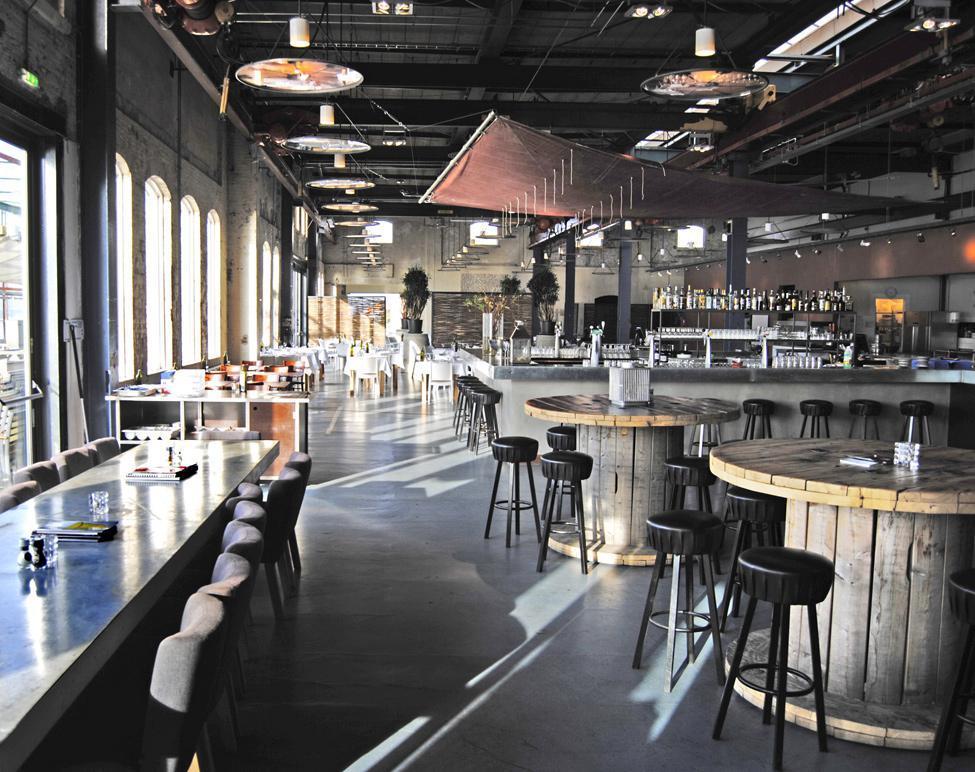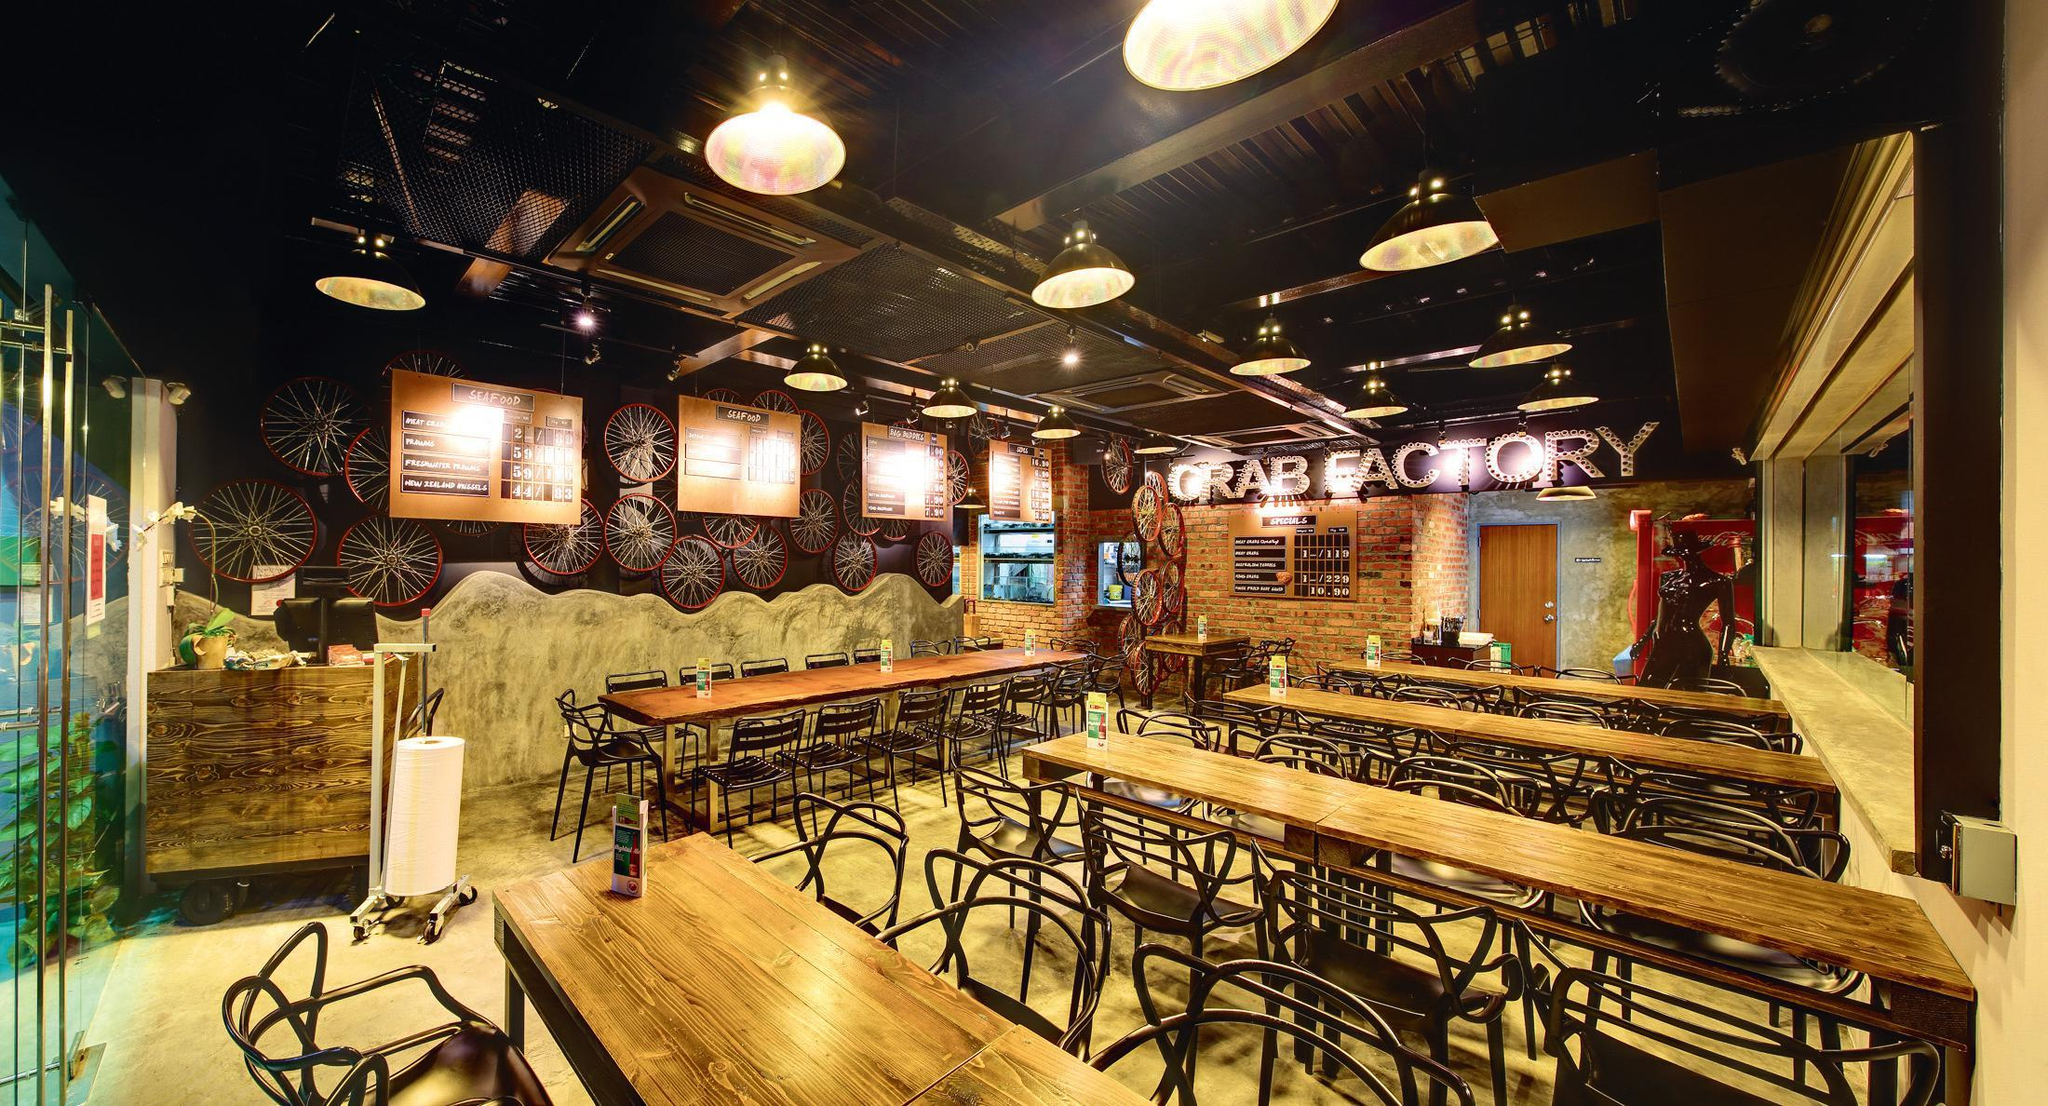The first image is the image on the left, the second image is the image on the right. Considering the images on both sides, is "The tables in the right image are long bench style tables." valid? Answer yes or no. Yes. 